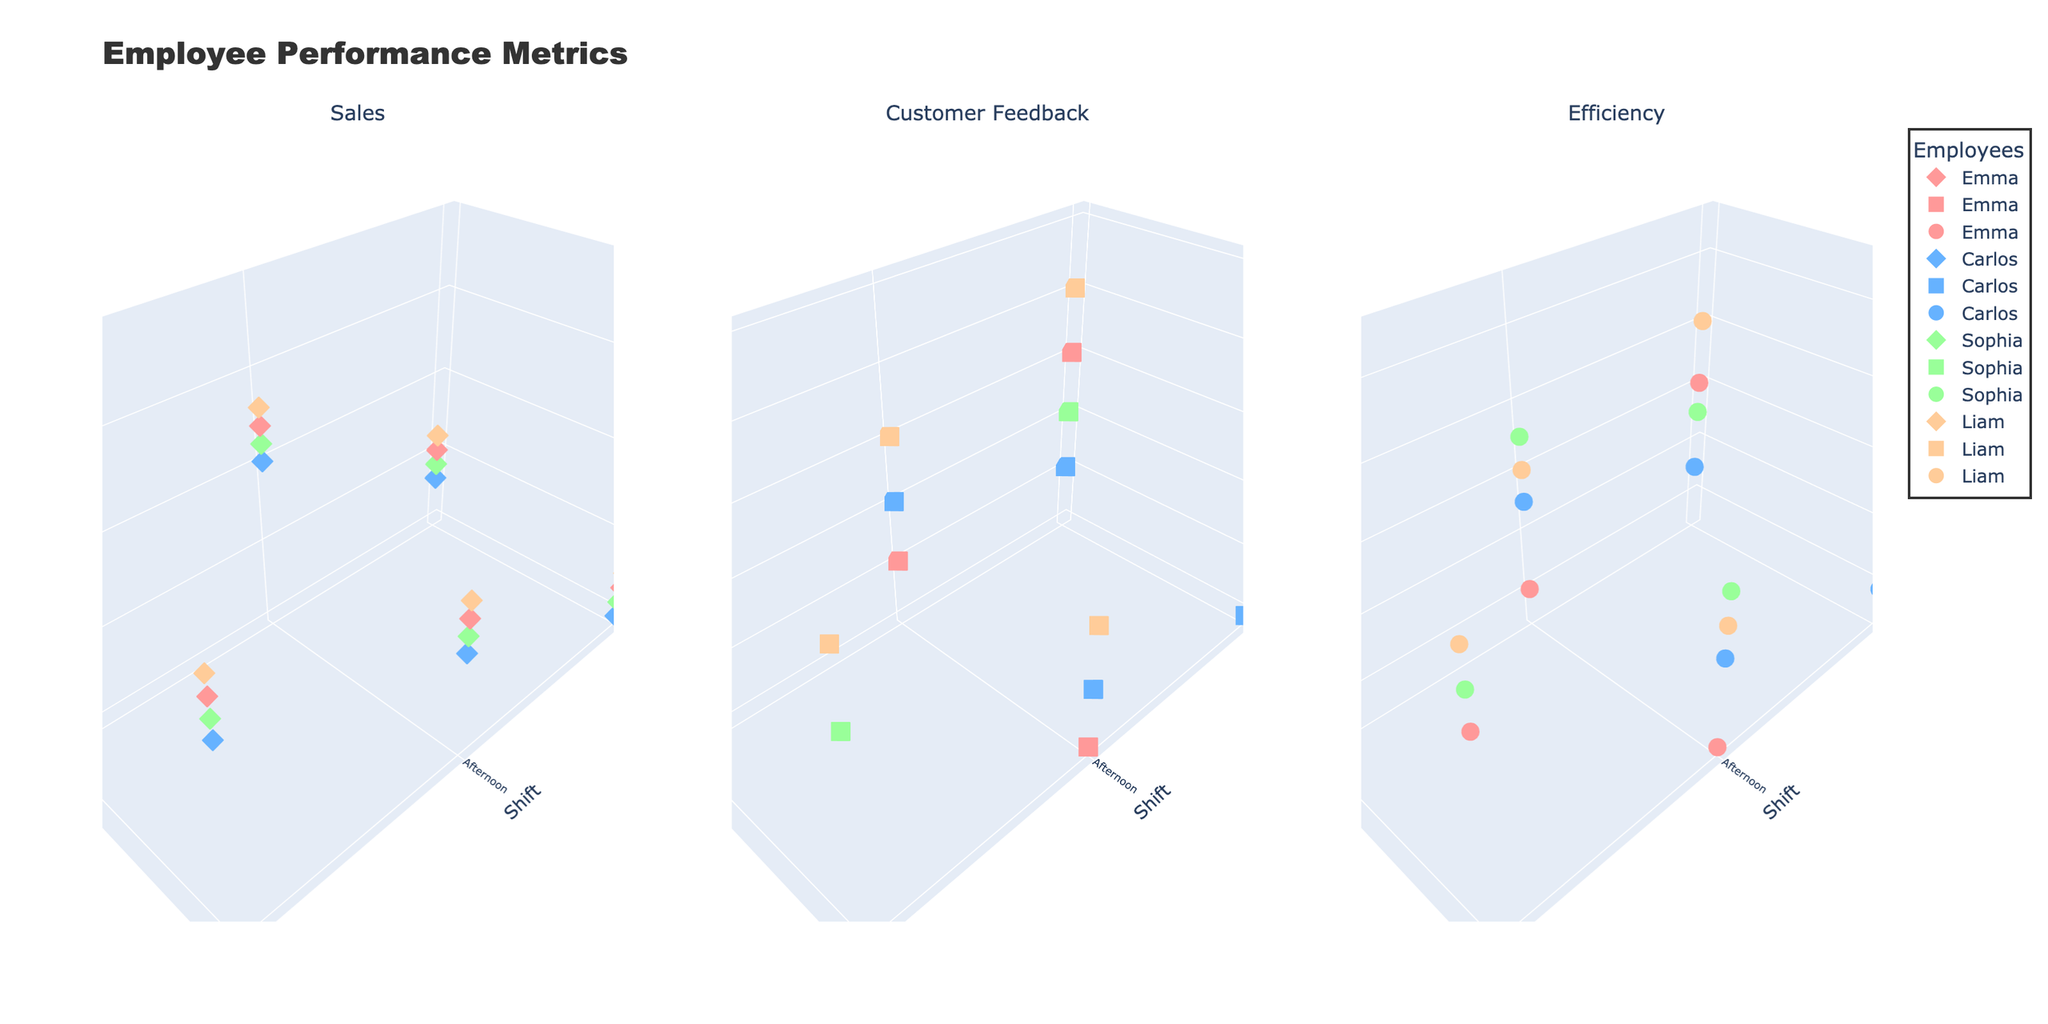What is the main title of the figure? The main title is displayed at the top of the figure and provides an overall description of the data visualization.
Answer: Employee Performance Metrics How many employees are represented in the figure? The figure legend shows markers and names of all the represented employees. There are four distinct employees visible.
Answer: 4 What shift and season combination yielded the highest sales for Emma? Emma's sales data can be found in the first subplot (Sales), and the highest z-axis value for the 'Emma' marker is observed. It corresponds to the Evening shift during Summer season.
Answer: Evening, Summer Which employee received the highest customer feedback in the winter season? Checking the z-axis values in the Customer Feedback subplot (the middle plot), the highest feedback value in winter can be identified and the corresponding employee can be seen by its color in the legend. Liam has the highest feedback value of 4.8 during winter.
Answer: Liam Compare the efficiency scores of Carlos and Sophia during the Summer season. Who performed better? In the Efficiency subplot (the third plot), locate the markers for Carlos and Sophia in the Summer season and compare their z-axis values. Sophia's efficiency scores should be 91, 93, and 95 while Carlos’s are 89, 91, and 96. Carlos has a higher individual maximum score of 96 compared to Sophia's 95, but observing the overall trend in multiple points provides a clearer comparison.
Answer: Carlos What are the average sales for Liam during the Winter season? In the Sales subplot, the sales for Liam during Winter are seen at shifts 'Morning' (2300), 'Afternoon' (2900), and 'Evening' (3400). Adding these values and dividing by the number of points (3) gives the average (2300 + 2900 + 3400) / 3 = 2866.67.
Answer: 2866.67 Which shift generally shows the highest efficiency across all employees? Investigate the markers' relative heights in the Efficiency subplot (third) and determine which shift markers often appear highest compared to the others. Evening shifts consistently have higher values.
Answer: Evening What is the relationship between Customer Feedback and seasonality for Sophia? Using the Customer Feedback subplot (second plot), observe the trends between Summer and Winter for Sophia's markers. Sophia's feedback mostly ranges from 4.6 to 4.8 and does not show drastic change between seasons.
Answer: No significant change Across all employees, what is the observed trend in sales when comparing morning to evening shifts in the Summer season? Inspect the Sales subplot and compare morning and evening shift markers for each employee within the Summer season. It is evident that sales are consistently higher during the Evening shifts compared to the Morning shifts for all employees in Summer.
Answer: Higher in Evening Did Liam's efficiency increase, decrease or stay the same from Afternoon to Evening shifts during Winter? Referencing Liam's markers and their z-axis values in the Efficiency subplot for Afternoon and Evening shifts during Winter, the efficiency moves from 91 to 95, indicating an increase.
Answer: Increase 